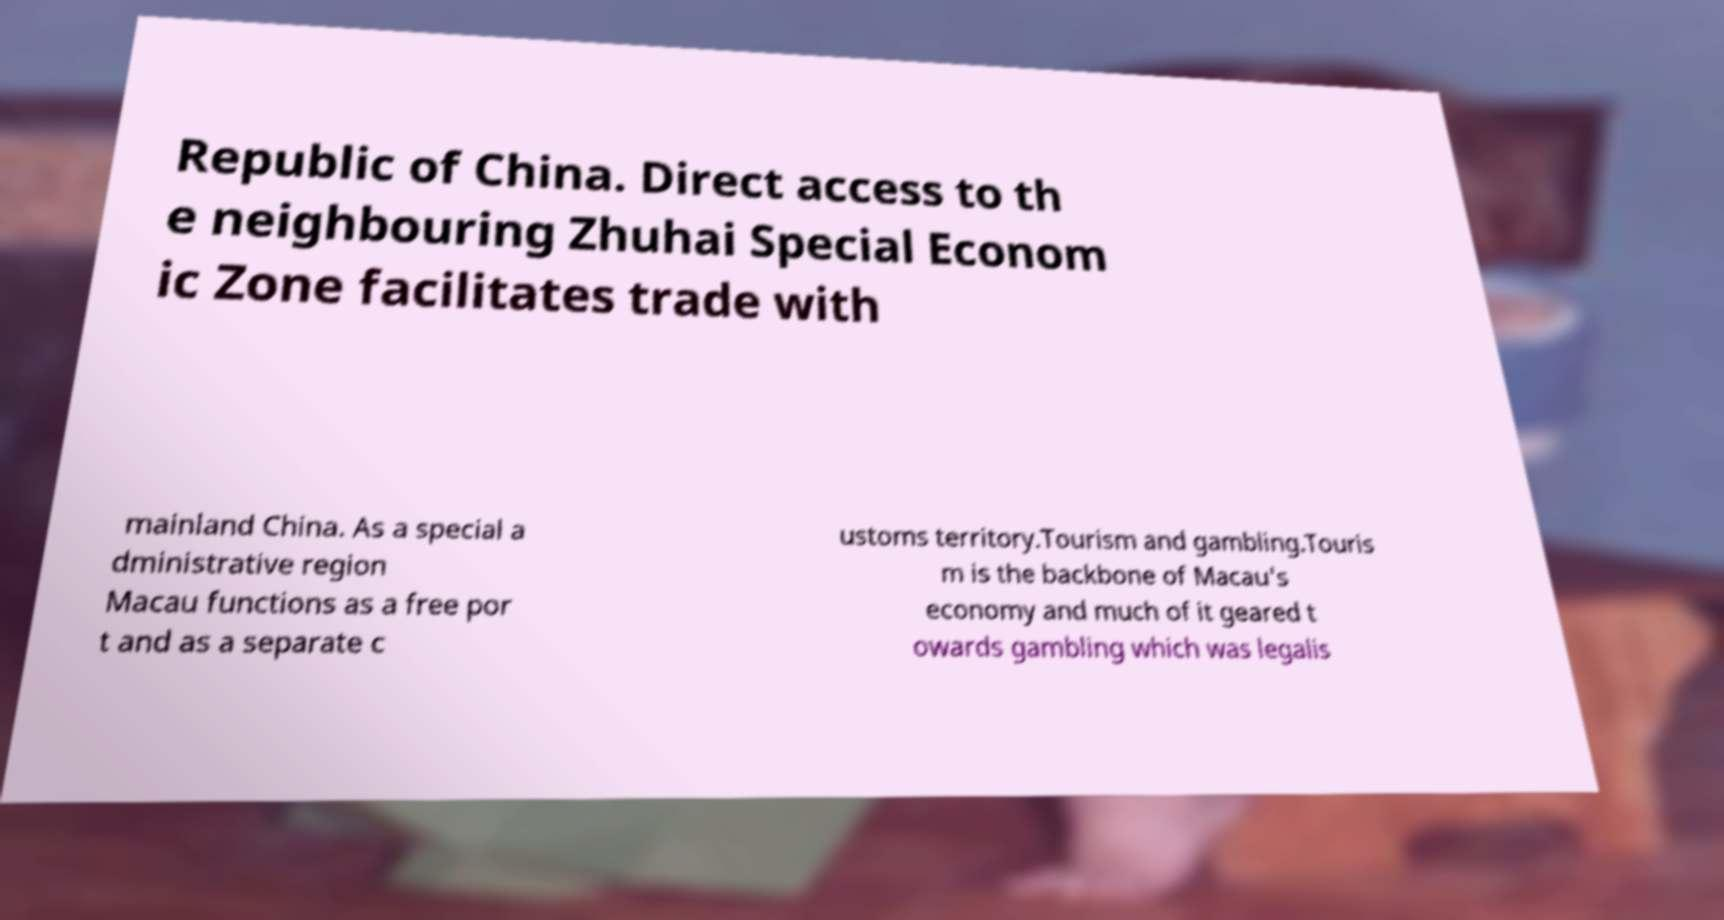Please read and relay the text visible in this image. What does it say? Republic of China. Direct access to th e neighbouring Zhuhai Special Econom ic Zone facilitates trade with mainland China. As a special a dministrative region Macau functions as a free por t and as a separate c ustoms territory.Tourism and gambling.Touris m is the backbone of Macau's economy and much of it geared t owards gambling which was legalis 